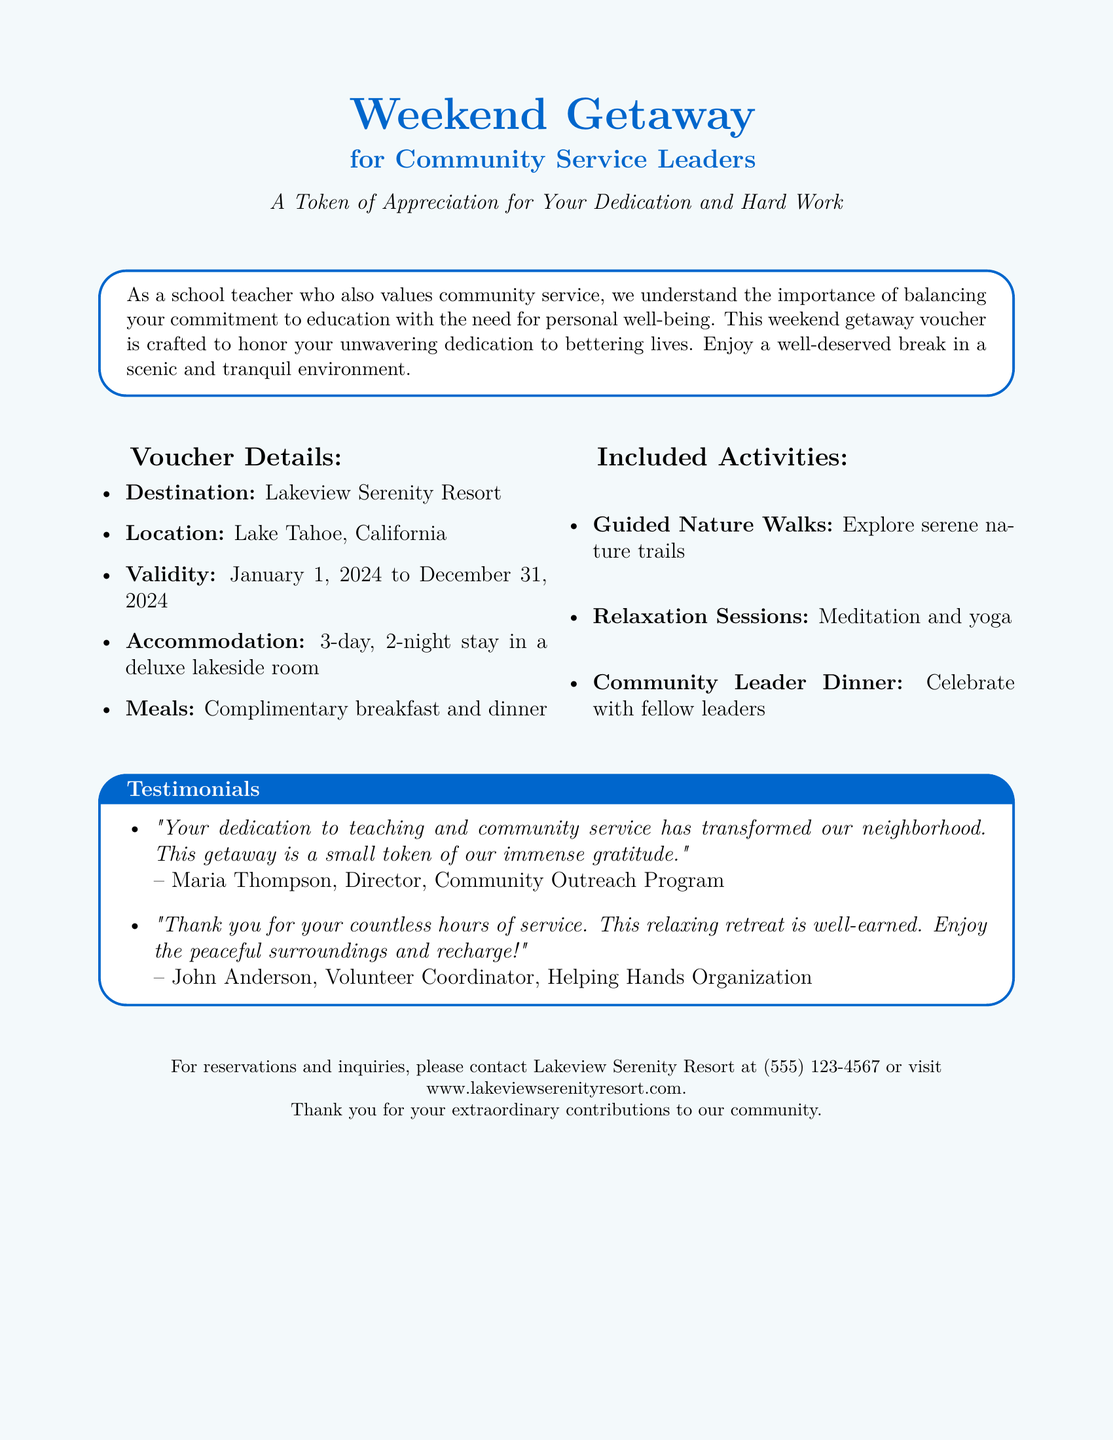What is the destination of the voucher? The destination is specified in the document as Lakeview Serenity Resort.
Answer: Lakeview Serenity Resort What is the location of the getaway? The document provides the location as Lake Tahoe, California.
Answer: Lake Tahoe, California What is the validity period of the voucher? The validity date is stated in the document, running from January 1, 2024 to December 31, 2024.
Answer: January 1, 2024 to December 31, 2024 How many nights does the stay include? The document mentions a 2-night stay as part of the voucher details.
Answer: 2 nights What type of meals are included? The types of meals included in the voucher are specified in the document as complimentary breakfast and dinner.
Answer: Complimentary breakfast and dinner What is one of the included activities? The document lists several activities, one being guided nature walks.
Answer: Guided Nature Walks Who is the Director of the Community Outreach Program? The document includes a testimonial with the name of the Director of the Community Outreach Program as Maria Thompson.
Answer: Maria Thompson What is the purpose of the voucher? The purpose of the voucher is described in the document as a token of appreciation for dedication and hard work.
Answer: A Token of Appreciation for Your Dedication and Hard Work What should you do for reservations? The document advises to contact Lakeview Serenity Resort for reservations.
Answer: Contact Lakeview Serenity Resort 